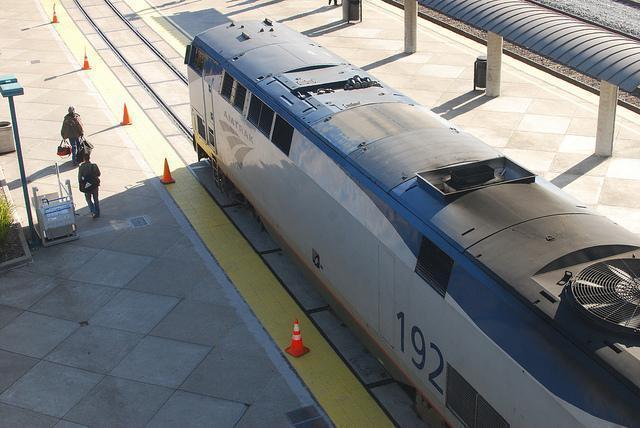What is the sum of the three digits on the train?
From the following four choices, select the correct answer to address the question.
Options: 12, 82, four, 25. 12. 